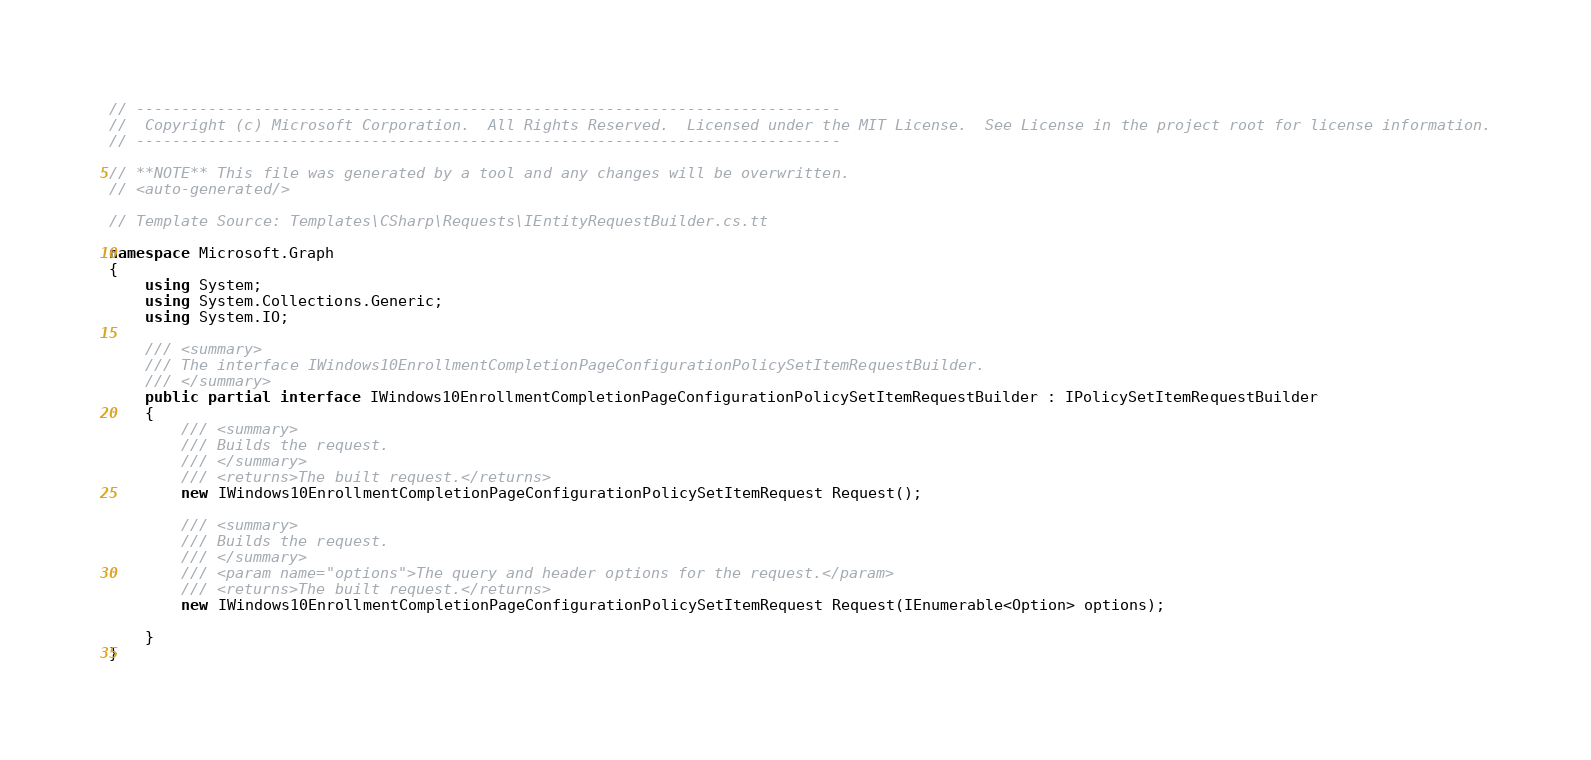Convert code to text. <code><loc_0><loc_0><loc_500><loc_500><_C#_>// ------------------------------------------------------------------------------
//  Copyright (c) Microsoft Corporation.  All Rights Reserved.  Licensed under the MIT License.  See License in the project root for license information.
// ------------------------------------------------------------------------------

// **NOTE** This file was generated by a tool and any changes will be overwritten.
// <auto-generated/>

// Template Source: Templates\CSharp\Requests\IEntityRequestBuilder.cs.tt

namespace Microsoft.Graph
{
    using System;
    using System.Collections.Generic;
    using System.IO;

    /// <summary>
    /// The interface IWindows10EnrollmentCompletionPageConfigurationPolicySetItemRequestBuilder.
    /// </summary>
    public partial interface IWindows10EnrollmentCompletionPageConfigurationPolicySetItemRequestBuilder : IPolicySetItemRequestBuilder
    {
        /// <summary>
        /// Builds the request.
        /// </summary>
        /// <returns>The built request.</returns>
        new IWindows10EnrollmentCompletionPageConfigurationPolicySetItemRequest Request();

        /// <summary>
        /// Builds the request.
        /// </summary>
        /// <param name="options">The query and header options for the request.</param>
        /// <returns>The built request.</returns>
        new IWindows10EnrollmentCompletionPageConfigurationPolicySetItemRequest Request(IEnumerable<Option> options);
    
    }
}
</code> 